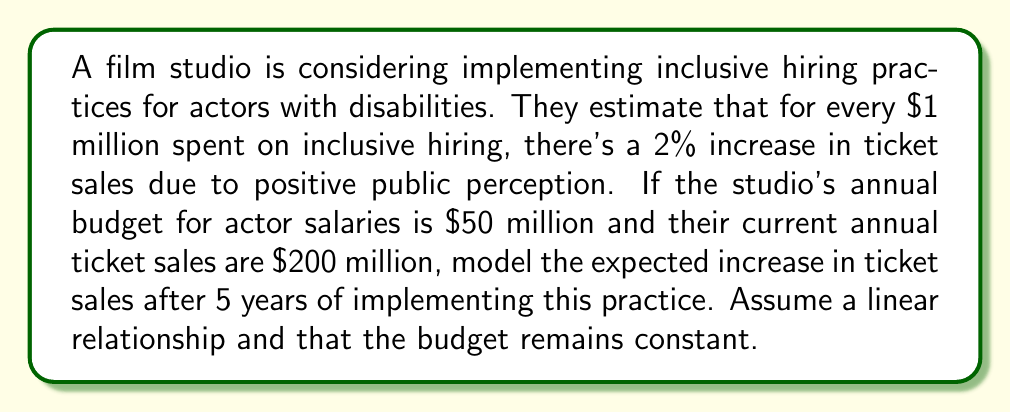Teach me how to tackle this problem. Let's approach this step-by-step:

1) First, let's define our variables:
   $x$ = number of years
   $y$ = increase in ticket sales (in millions of dollars)

2) We're told that for every $1 million spent on inclusive hiring, there's a 2% increase in ticket sales.
   The studio's annual budget for actor salaries is $50 million.
   So, the annual increase in ticket sales would be:
   $50 \times 2\% = 100\%$ of current ticket sales

3) Current annual ticket sales are $200 million.
   So, the annual increase in ticket sales would be:
   $200 \text{ million} \times 100\% = 200 \text{ million dollars}$

4) We can now set up a linear equation:
   $y = mx + b$
   Where $m$ is the slope (annual increase) and $b$ is the y-intercept (initial increase, which is 0)

5) Our equation becomes:
   $y = 200x$

6) To find the increase after 5 years, we substitute $x = 5$:
   $y = 200 \times 5 = 1000$

Therefore, the expected increase in ticket sales after 5 years is $1000 million, or $1 billion.
Answer: $1 billion 